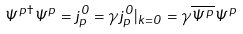<formula> <loc_0><loc_0><loc_500><loc_500>\Psi ^ { p \dagger } \Psi ^ { p } = j ^ { 0 } _ { p } = \gamma j ^ { 0 } _ { p } | _ { k = 0 } = \gamma \overline { \Psi ^ { p } } \Psi ^ { p }</formula> 